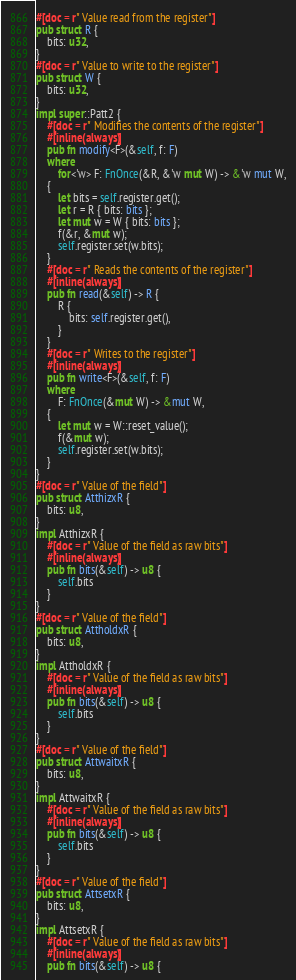Convert code to text. <code><loc_0><loc_0><loc_500><loc_500><_Rust_>#[doc = r" Value read from the register"]
pub struct R {
    bits: u32,
}
#[doc = r" Value to write to the register"]
pub struct W {
    bits: u32,
}
impl super::Patt2 {
    #[doc = r" Modifies the contents of the register"]
    #[inline(always)]
    pub fn modify<F>(&self, f: F)
    where
        for<'w> F: FnOnce(&R, &'w mut W) -> &'w mut W,
    {
        let bits = self.register.get();
        let r = R { bits: bits };
        let mut w = W { bits: bits };
        f(&r, &mut w);
        self.register.set(w.bits);
    }
    #[doc = r" Reads the contents of the register"]
    #[inline(always)]
    pub fn read(&self) -> R {
        R {
            bits: self.register.get(),
        }
    }
    #[doc = r" Writes to the register"]
    #[inline(always)]
    pub fn write<F>(&self, f: F)
    where
        F: FnOnce(&mut W) -> &mut W,
    {
        let mut w = W::reset_value();
        f(&mut w);
        self.register.set(w.bits);
    }
}
#[doc = r" Value of the field"]
pub struct AtthizxR {
    bits: u8,
}
impl AtthizxR {
    #[doc = r" Value of the field as raw bits"]
    #[inline(always)]
    pub fn bits(&self) -> u8 {
        self.bits
    }
}
#[doc = r" Value of the field"]
pub struct AttholdxR {
    bits: u8,
}
impl AttholdxR {
    #[doc = r" Value of the field as raw bits"]
    #[inline(always)]
    pub fn bits(&self) -> u8 {
        self.bits
    }
}
#[doc = r" Value of the field"]
pub struct AttwaitxR {
    bits: u8,
}
impl AttwaitxR {
    #[doc = r" Value of the field as raw bits"]
    #[inline(always)]
    pub fn bits(&self) -> u8 {
        self.bits
    }
}
#[doc = r" Value of the field"]
pub struct AttsetxR {
    bits: u8,
}
impl AttsetxR {
    #[doc = r" Value of the field as raw bits"]
    #[inline(always)]
    pub fn bits(&self) -> u8 {</code> 